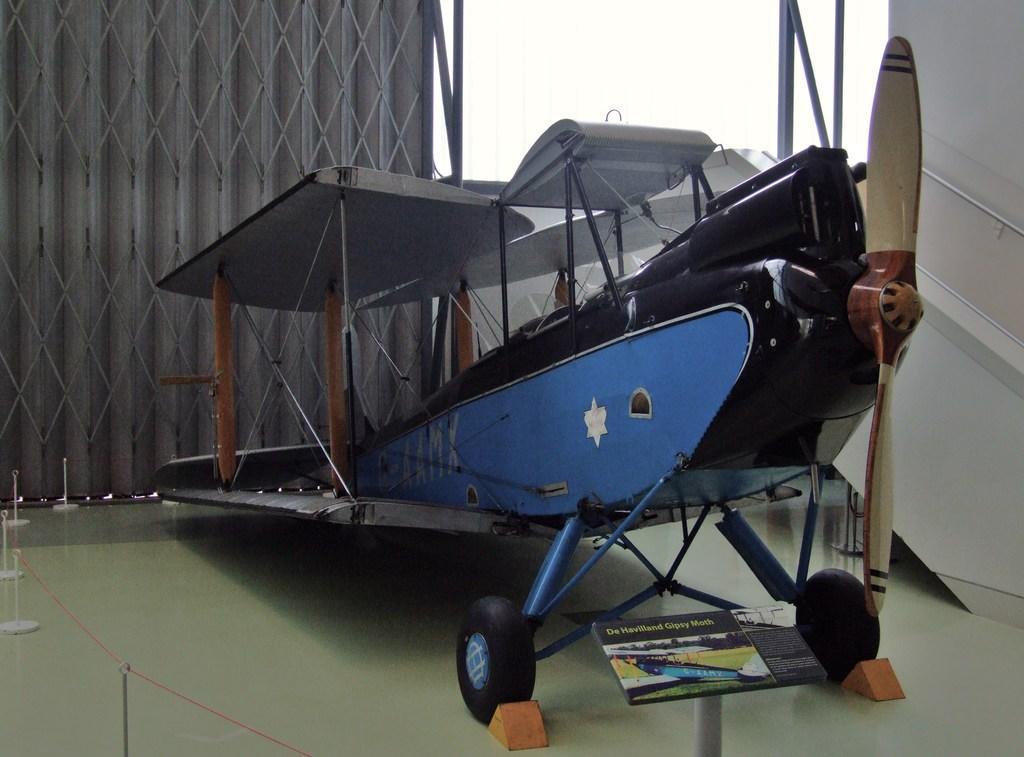How would you summarize this image in a sentence or two? In this picture we can see an aircraft, at the bottom there is a board, on the left side we can see a thread, we can see propeller of aircraft on the right side. 